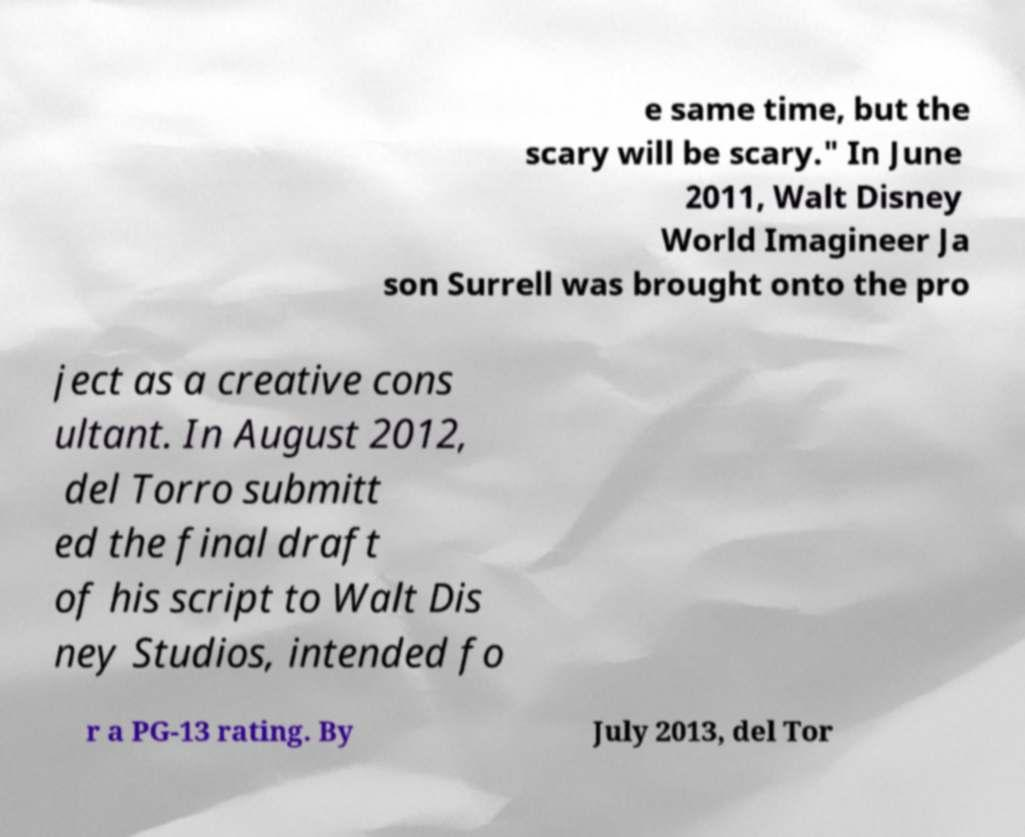Please identify and transcribe the text found in this image. e same time, but the scary will be scary." In June 2011, Walt Disney World Imagineer Ja son Surrell was brought onto the pro ject as a creative cons ultant. In August 2012, del Torro submitt ed the final draft of his script to Walt Dis ney Studios, intended fo r a PG-13 rating. By July 2013, del Tor 